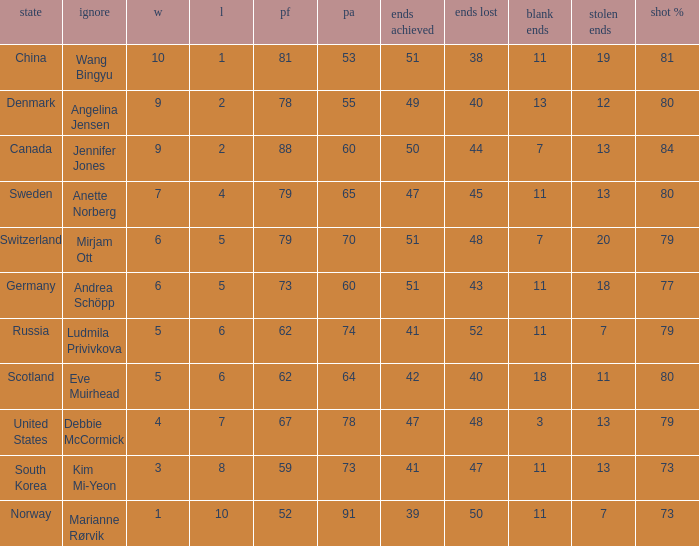Andrea Schöpp is the skip of which country? Germany. 